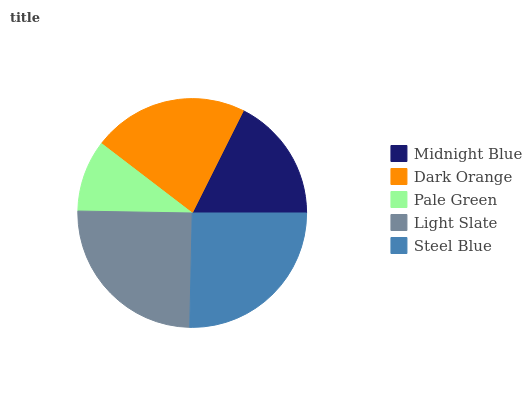Is Pale Green the minimum?
Answer yes or no. Yes. Is Steel Blue the maximum?
Answer yes or no. Yes. Is Dark Orange the minimum?
Answer yes or no. No. Is Dark Orange the maximum?
Answer yes or no. No. Is Dark Orange greater than Midnight Blue?
Answer yes or no. Yes. Is Midnight Blue less than Dark Orange?
Answer yes or no. Yes. Is Midnight Blue greater than Dark Orange?
Answer yes or no. No. Is Dark Orange less than Midnight Blue?
Answer yes or no. No. Is Dark Orange the high median?
Answer yes or no. Yes. Is Dark Orange the low median?
Answer yes or no. Yes. Is Steel Blue the high median?
Answer yes or no. No. Is Pale Green the low median?
Answer yes or no. No. 